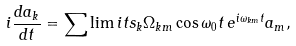<formula> <loc_0><loc_0><loc_500><loc_500>i \frac { d a _ { k } } { d t } = \sum \lim i t s _ { k } { \Omega _ { k m } \cos \omega _ { 0 } t \, e ^ { i \omega _ { k m } t } a _ { m } } ,</formula> 